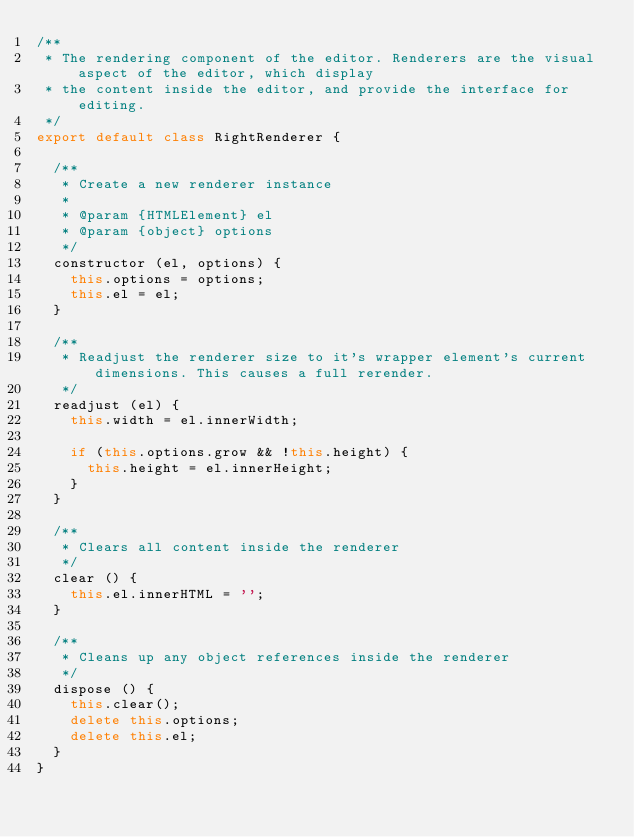Convert code to text. <code><loc_0><loc_0><loc_500><loc_500><_JavaScript_>/**
 * The rendering component of the editor. Renderers are the visual aspect of the editor, which display
 * the content inside the editor, and provide the interface for editing.
 */
export default class RightRenderer {

  /**
   * Create a new renderer instance
   * 
   * @param {HTMLElement} el 
   * @param {object} options 
   */
  constructor (el, options) {
    this.options = options;
    this.el = el;
  }

  /**
   * Readjust the renderer size to it's wrapper element's current dimensions. This causes a full rerender.
   */
  readjust (el) {
    this.width = el.innerWidth;

    if (this.options.grow && !this.height) {
      this.height = el.innerHeight;
    }
  }

  /**
   * Clears all content inside the renderer
   */
  clear () {
    this.el.innerHTML = '';
  }

  /**
   * Cleans up any object references inside the renderer
   */
  dispose () {
    this.clear();
    delete this.options;
    delete this.el;
  }
}</code> 